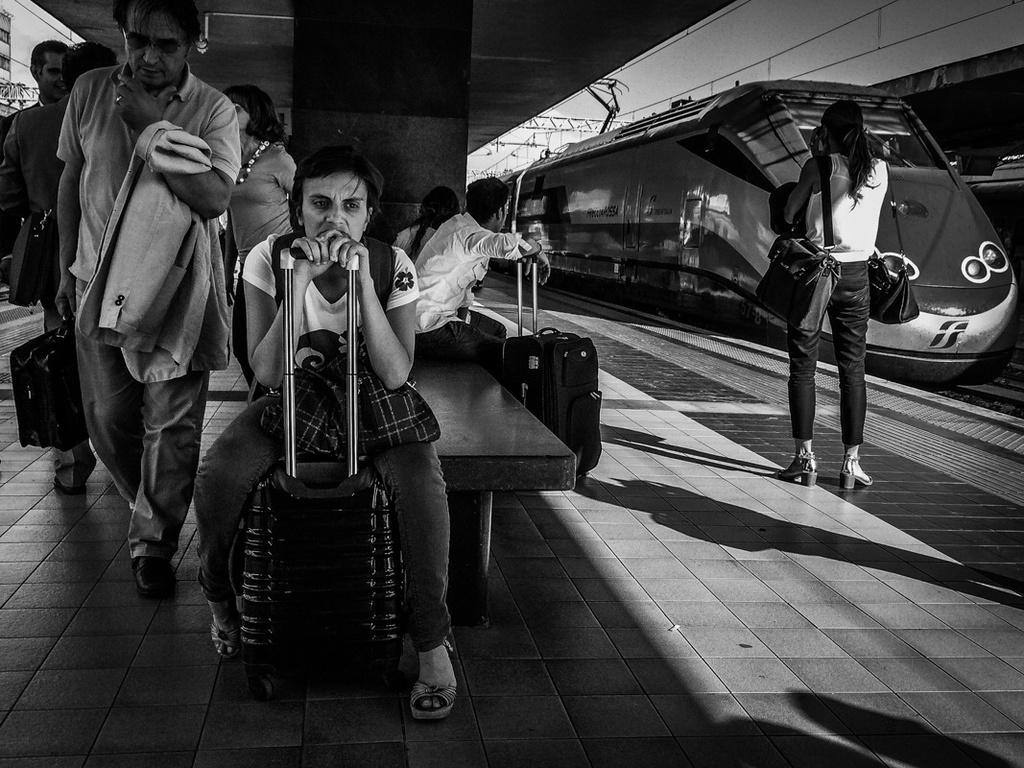What is the color scheme of the image? The image is black and white. What can be seen on the track in the image? There is a train on the track in the image. Can you describe the people in the image? There are people visible in the image, some of whom are sitting and holding their luggage. What is the woman wearing in the image? There is a woman wearing bags in the image. What type of ship can be seen sailing in the background of the image? There is no ship visible in the image; it is a black and white image featuring a train on a track. What scent is associated with the woman wearing bags in the image? There is no information about the scent associated with the woman wearing bags in the image. 